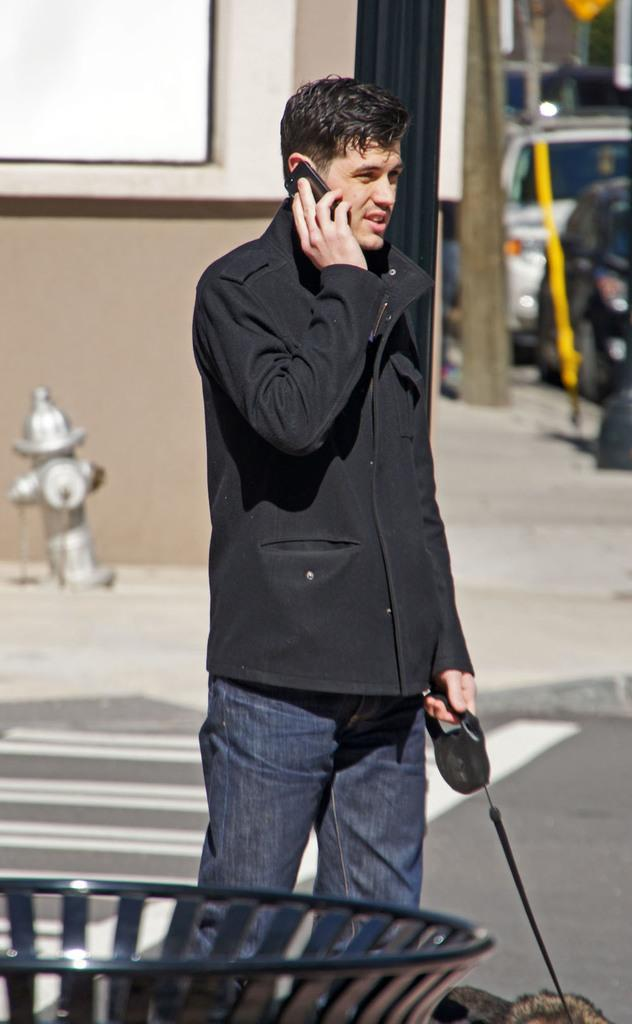What is the person in the image holding? The person is holding a dog and a mobile phone. What else can be seen in the image besides the person and the dog? There are vehicles, buildings, a hydrant, and poles in the image. What type of salt is being sprinkled on the person's hand in the image? There is no salt or hand-sprinkling activity present in the image. 